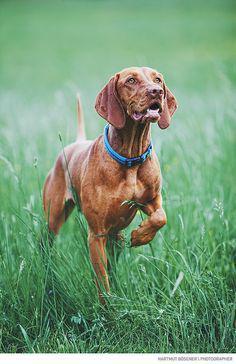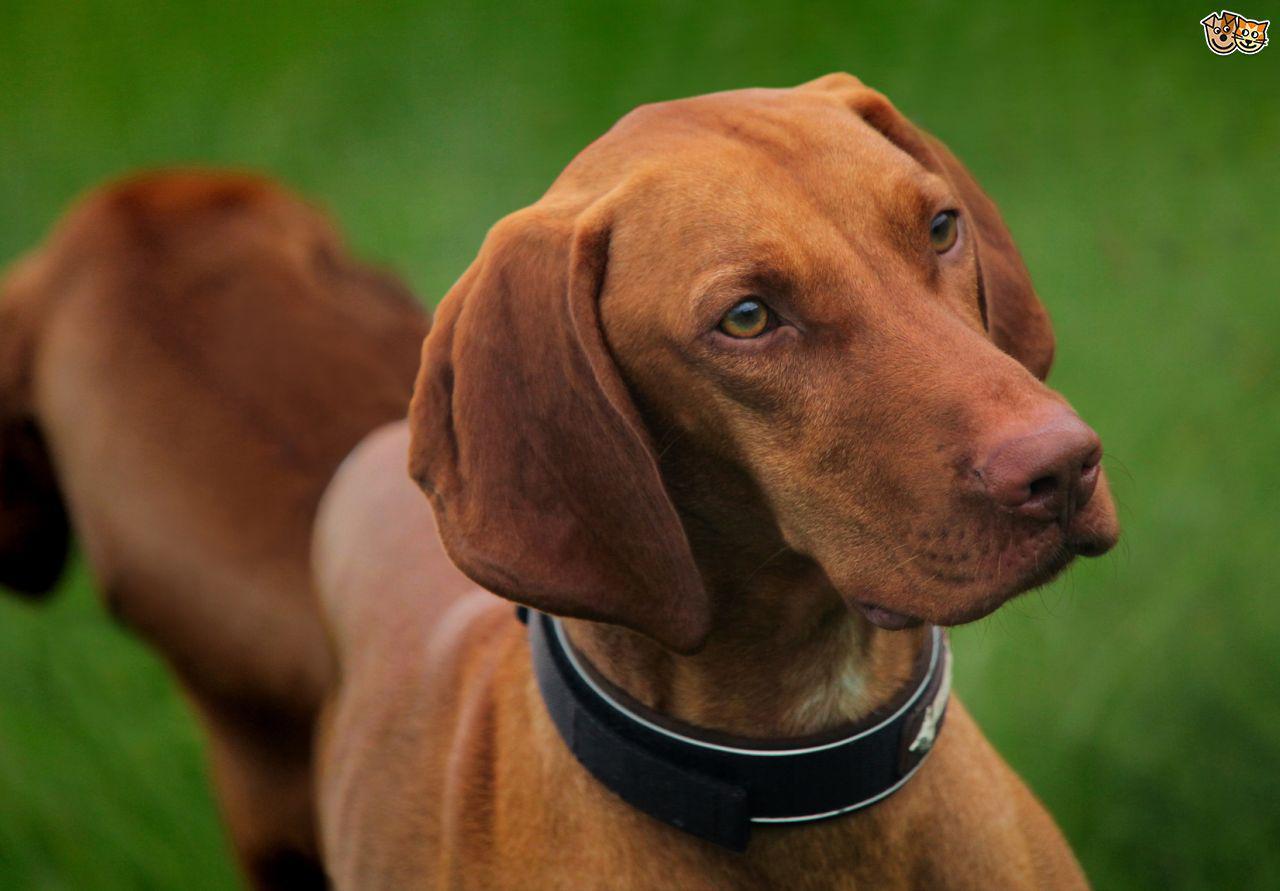The first image is the image on the left, the second image is the image on the right. Evaluate the accuracy of this statement regarding the images: "One of the images shows a dog standing in green grass with a leg up in the air.". Is it true? Answer yes or no. Yes. The first image is the image on the left, the second image is the image on the right. Assess this claim about the two images: "One image shows a standing dog holding a long tan item in its mouth.". Correct or not? Answer yes or no. No. 